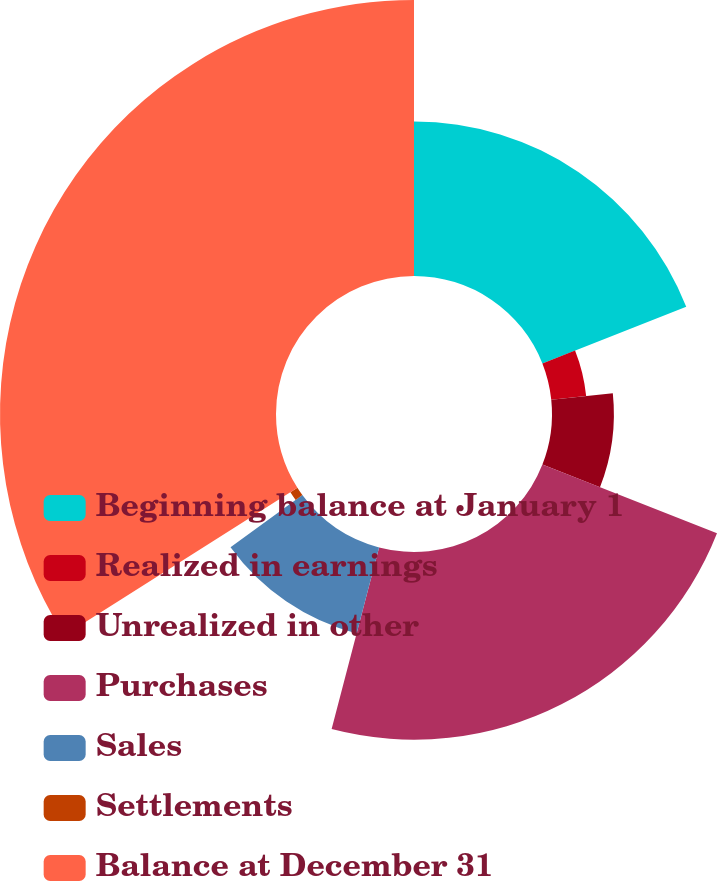<chart> <loc_0><loc_0><loc_500><loc_500><pie_chart><fcel>Beginning balance at January 1<fcel>Realized in earnings<fcel>Unrealized in other<fcel>Purchases<fcel>Sales<fcel>Settlements<fcel>Balance at December 31<nl><fcel>19.03%<fcel>4.32%<fcel>7.62%<fcel>23.1%<fcel>10.93%<fcel>1.02%<fcel>33.98%<nl></chart> 